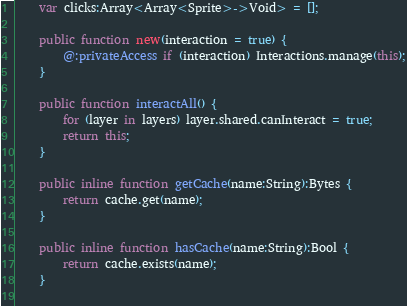<code> <loc_0><loc_0><loc_500><loc_500><_Haxe_>    var clicks:Array<Array<Sprite>->Void> = [];

    public function new(interaction = true) {
        @:privateAccess if (interaction) Interactions.manage(this);
    }

    public function interactAll() {
        for (layer in layers) layer.shared.canInteract = true;
        return this;
    }

    public inline function getCache(name:String):Bytes {
        return cache.get(name);
    }

    public inline function hasCache(name:String):Bool {
        return cache.exists(name);
    }
 </code> 